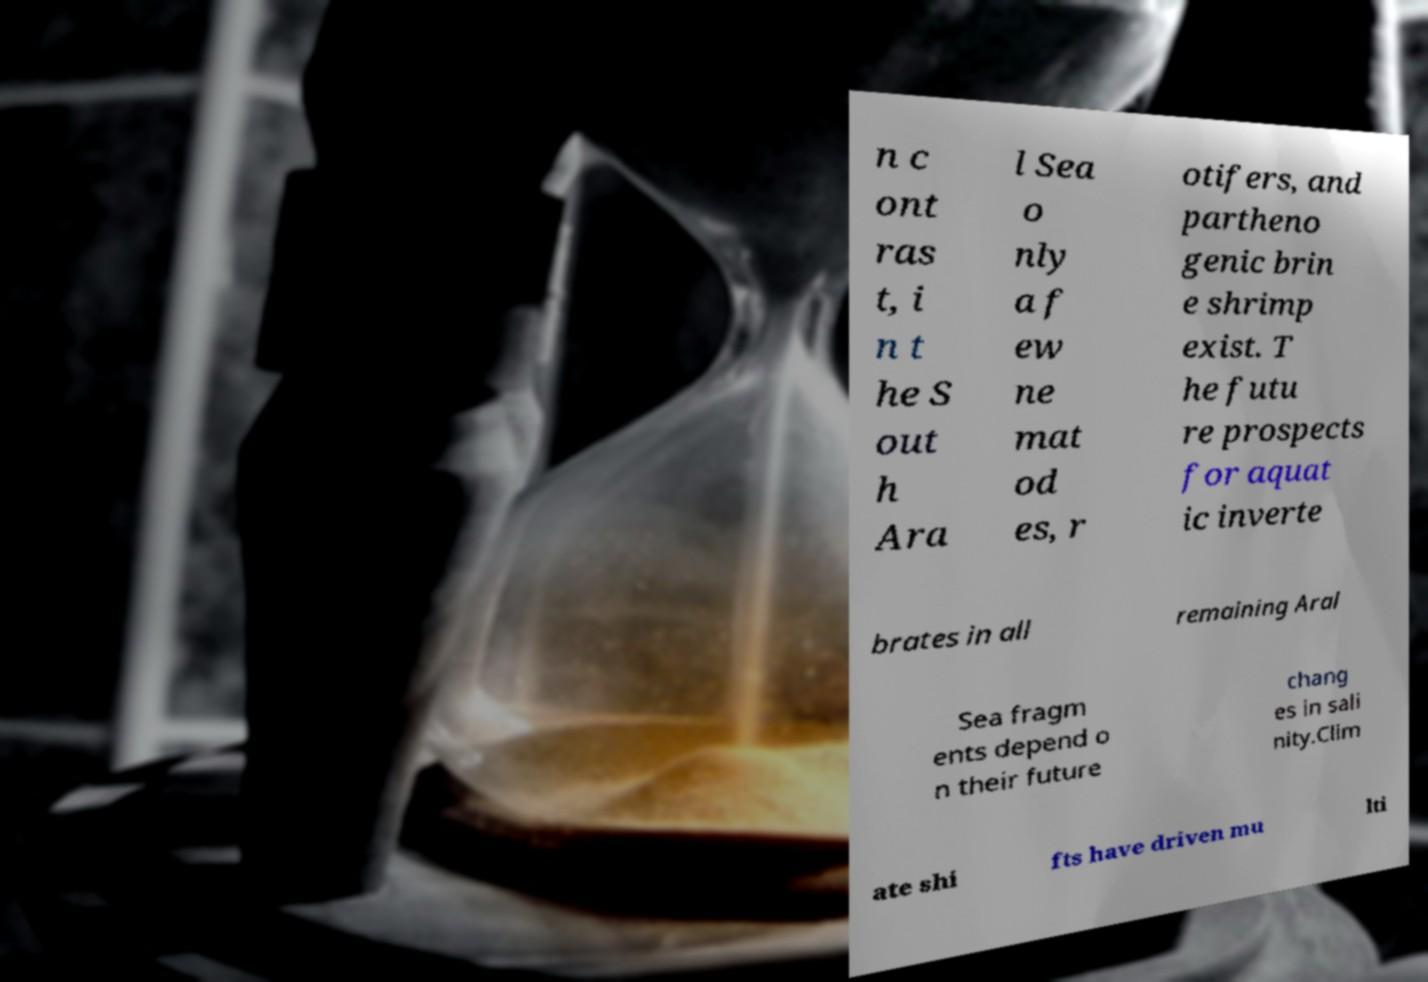Can you read and provide the text displayed in the image?This photo seems to have some interesting text. Can you extract and type it out for me? n c ont ras t, i n t he S out h Ara l Sea o nly a f ew ne mat od es, r otifers, and partheno genic brin e shrimp exist. T he futu re prospects for aquat ic inverte brates in all remaining Aral Sea fragm ents depend o n their future chang es in sali nity.Clim ate shi fts have driven mu lti 